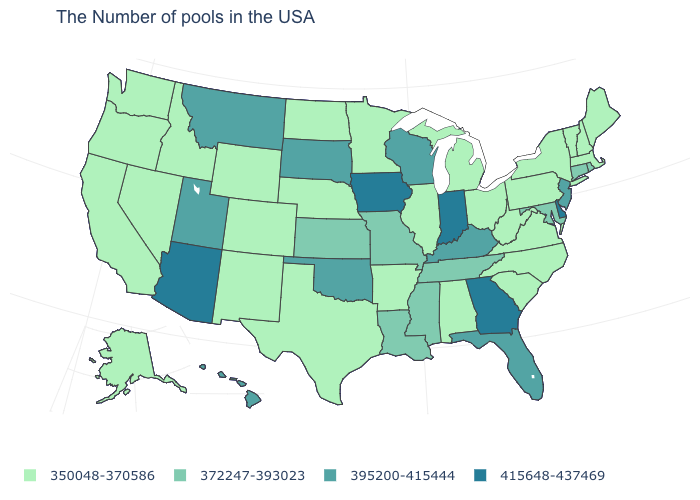Does the map have missing data?
Concise answer only. No. Which states hav the highest value in the MidWest?
Give a very brief answer. Indiana, Iowa. Is the legend a continuous bar?
Keep it brief. No. What is the value of California?
Be succinct. 350048-370586. What is the value of Delaware?
Short answer required. 415648-437469. Which states have the highest value in the USA?
Be succinct. Delaware, Georgia, Indiana, Iowa, Arizona. Is the legend a continuous bar?
Answer briefly. No. Name the states that have a value in the range 350048-370586?
Give a very brief answer. Maine, Massachusetts, New Hampshire, Vermont, New York, Pennsylvania, Virginia, North Carolina, South Carolina, West Virginia, Ohio, Michigan, Alabama, Illinois, Arkansas, Minnesota, Nebraska, Texas, North Dakota, Wyoming, Colorado, New Mexico, Idaho, Nevada, California, Washington, Oregon, Alaska. Does the first symbol in the legend represent the smallest category?
Quick response, please. Yes. What is the highest value in states that border Idaho?
Quick response, please. 395200-415444. Name the states that have a value in the range 350048-370586?
Write a very short answer. Maine, Massachusetts, New Hampshire, Vermont, New York, Pennsylvania, Virginia, North Carolina, South Carolina, West Virginia, Ohio, Michigan, Alabama, Illinois, Arkansas, Minnesota, Nebraska, Texas, North Dakota, Wyoming, Colorado, New Mexico, Idaho, Nevada, California, Washington, Oregon, Alaska. What is the lowest value in the Northeast?
Give a very brief answer. 350048-370586. Name the states that have a value in the range 395200-415444?
Write a very short answer. New Jersey, Florida, Kentucky, Wisconsin, Oklahoma, South Dakota, Utah, Montana, Hawaii. Among the states that border Indiana , does Ohio have the highest value?
Write a very short answer. No. Does Ohio have the lowest value in the USA?
Quick response, please. Yes. 